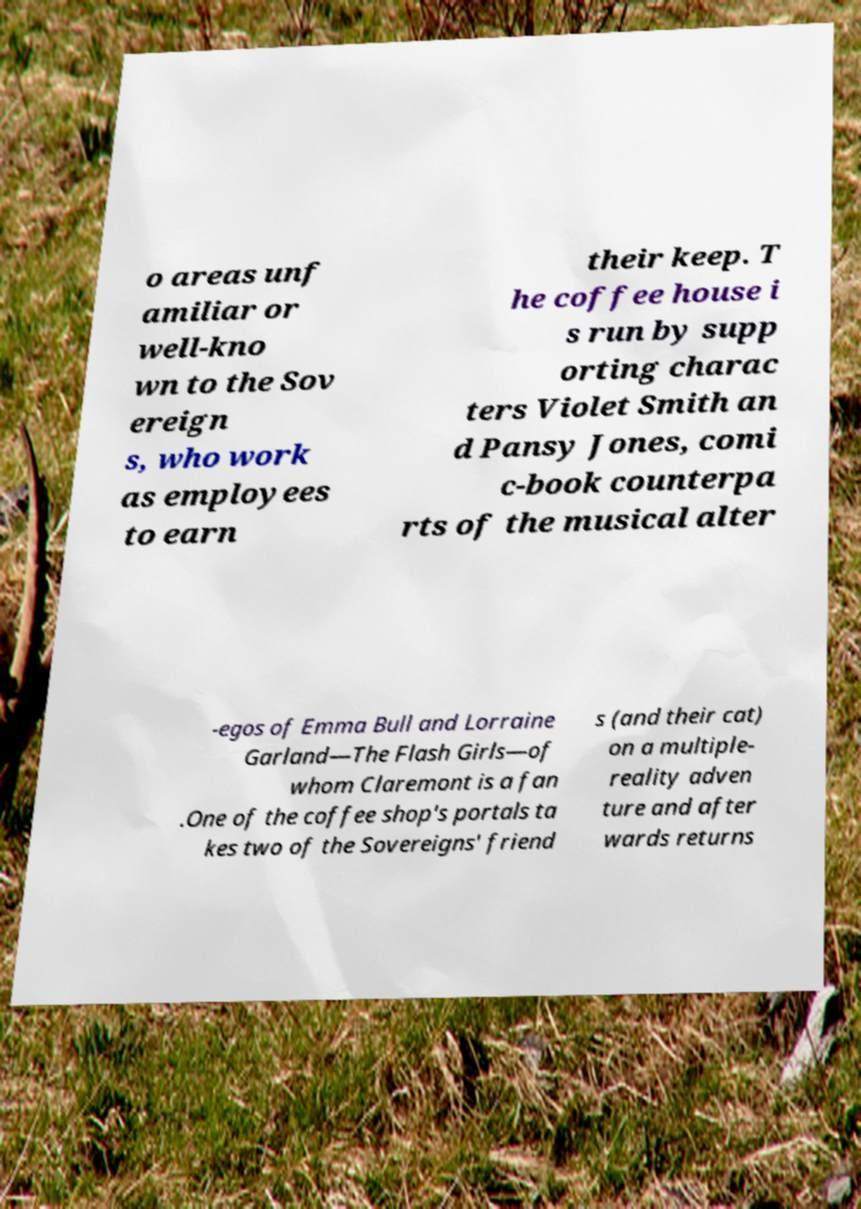Please identify and transcribe the text found in this image. o areas unf amiliar or well-kno wn to the Sov ereign s, who work as employees to earn their keep. T he coffee house i s run by supp orting charac ters Violet Smith an d Pansy Jones, comi c-book counterpa rts of the musical alter -egos of Emma Bull and Lorraine Garland—The Flash Girls—of whom Claremont is a fan .One of the coffee shop's portals ta kes two of the Sovereigns' friend s (and their cat) on a multiple- reality adven ture and after wards returns 